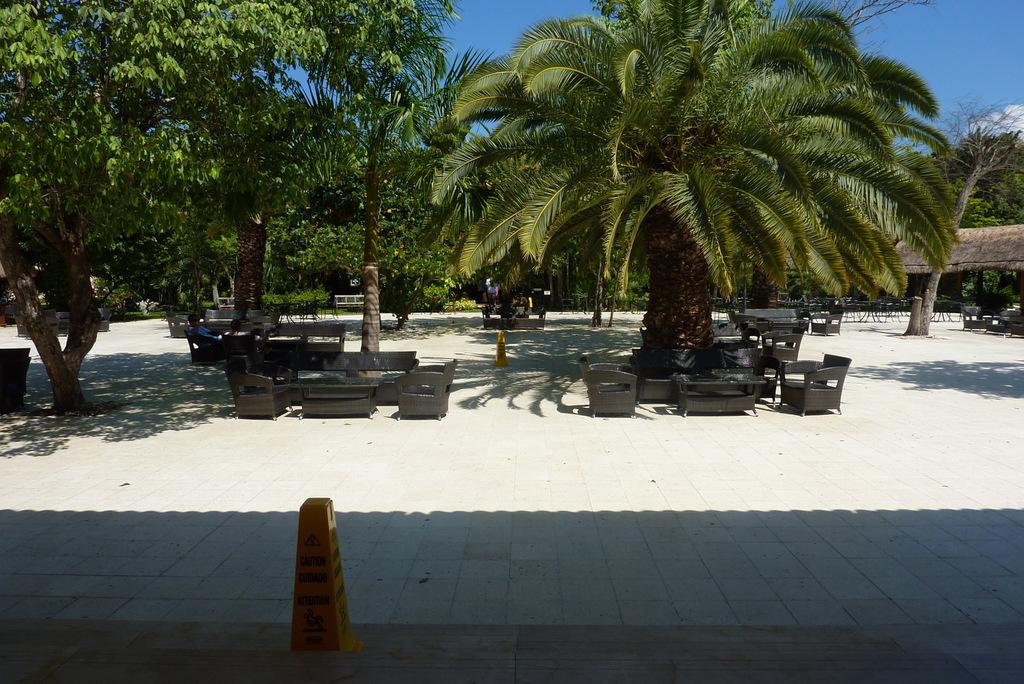What type of vegetation is present in the image? There are many trees in the image. What type of seating is available in the image? There are chairs and benches in the image. What are the yellow poles used for in the image? The yellow poles are likely used for marking or guiding purposes in the image. What can be seen in the background of the image? The sky is visible in the background of the image. Where is the dock located in the image? There is no dock present in the image. What type of lunch is being served in the image? There is no lunch being served in the image. 